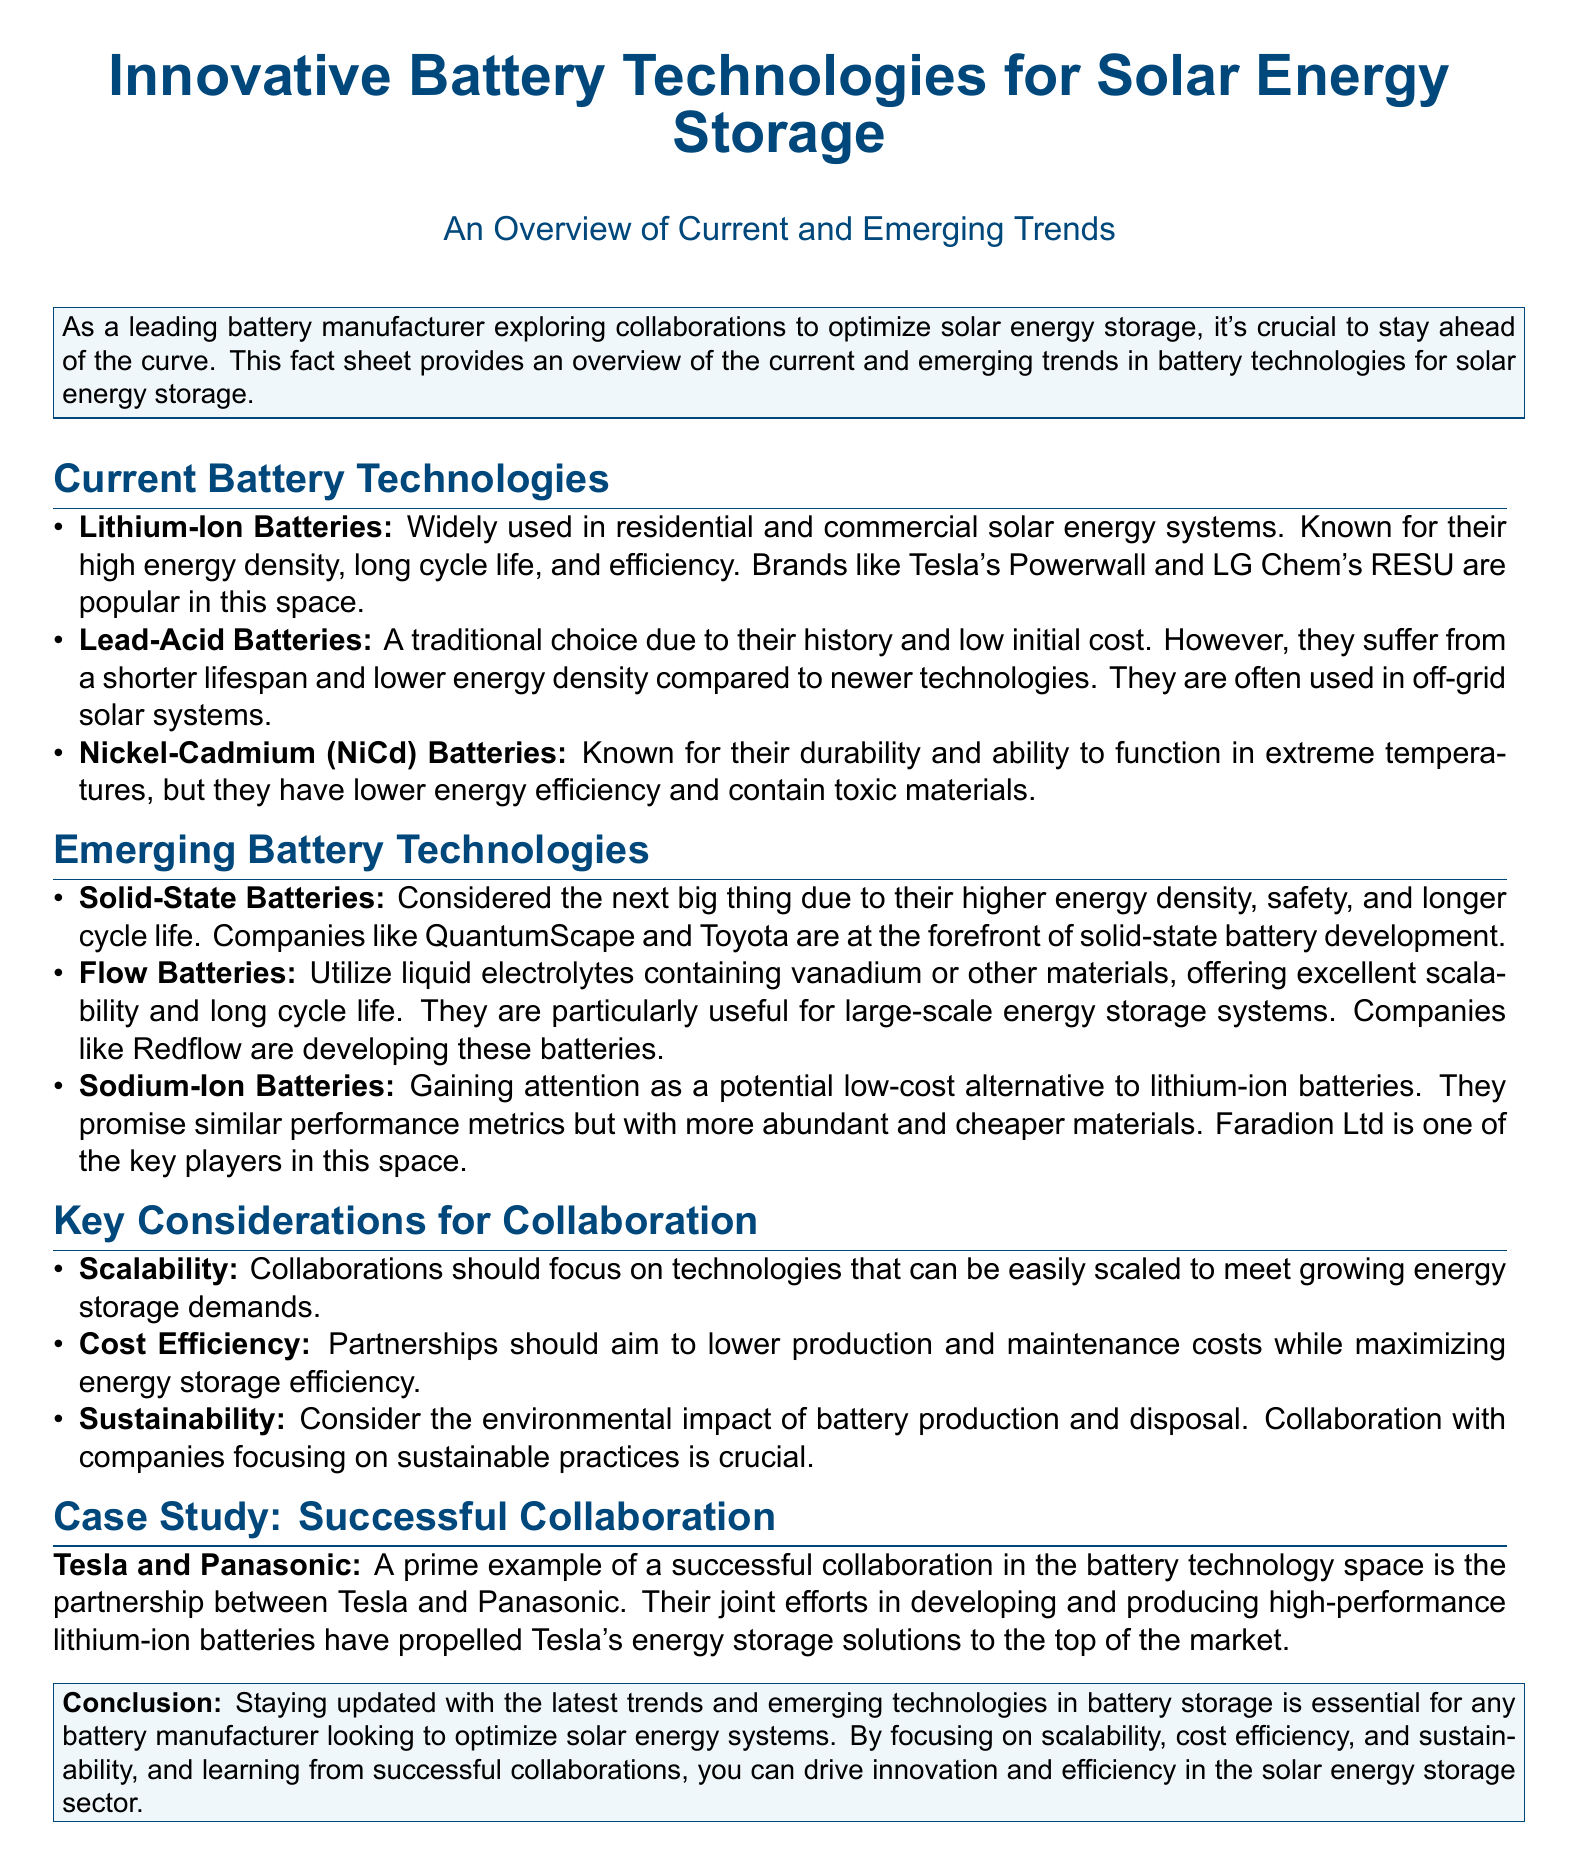What is the title of the document? The title is presented at the beginning of the document, indicating the main subject of the content.
Answer: Innovative Battery Technologies for Solar Energy Storage Which type of batteries is known for high energy density? The document lists various battery technologies accompanied by their characteristics, stating this specific quality for Lithium-Ion batteries.
Answer: Lithium-Ion Batteries What company is mentioned as a key player in solid-state battery development? The document highlights companies leading advancements in specific technologies, including this one for solid-state batteries.
Answer: QuantumScape What key consideration is emphasized for collaboration? The document lists three key considerations, one of which is inherent to successful partnerships in battery tech.
Answer: Scalability Which battery type is gaining attention as a low-cost alternative? The document indicates emerging technologies and specifies this battery type as a noteworthy alternative to lithium-ion batteries.
Answer: Sodium-Ion Batteries Who are the two companies involved in a successful collaboration case study? The document cites a notable partnership as a case study, highlighting both companies involved in that collaboration.
Answer: Tesla and Panasonic What is a major drawback of Lead-Acid batteries? The document outlines the disadvantages of various battery types, stating a specific drawback of Lead-Acid batteries.
Answer: Shorter lifespan What type of battery uses liquid electrolytes? The document describes emerging battery technologies and characterizes this type accordingly.
Answer: Flow Batteries 